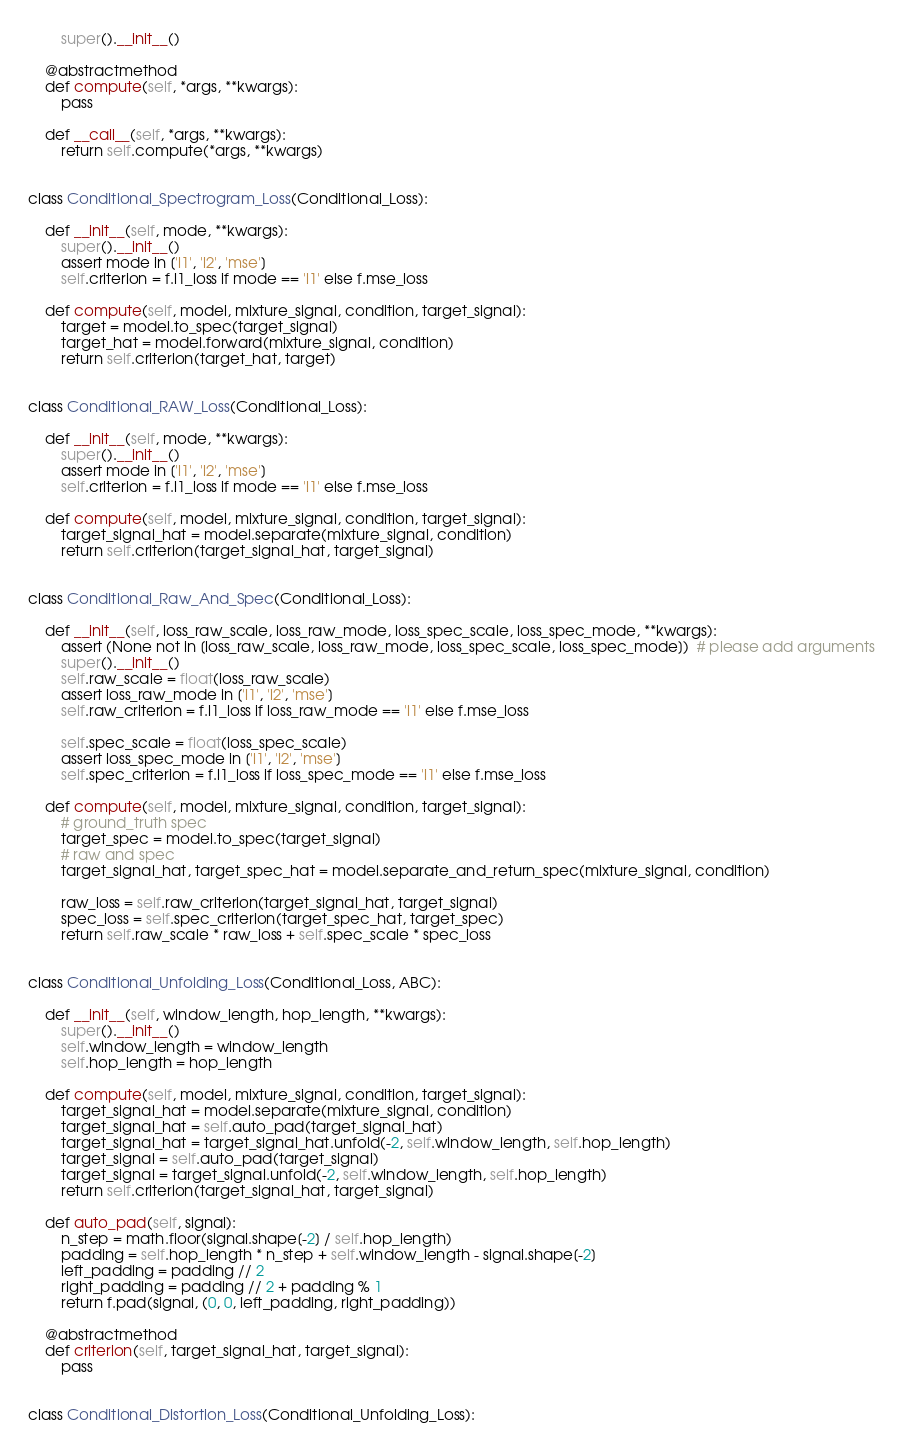Convert code to text. <code><loc_0><loc_0><loc_500><loc_500><_Python_>        super().__init__()

    @abstractmethod
    def compute(self, *args, **kwargs):
        pass

    def __call__(self, *args, **kwargs):
        return self.compute(*args, **kwargs)


class Conditional_Spectrogram_Loss(Conditional_Loss):

    def __init__(self, mode, **kwargs):
        super().__init__()
        assert mode in ['l1', 'l2', 'mse']
        self.criterion = f.l1_loss if mode == 'l1' else f.mse_loss

    def compute(self, model, mixture_signal, condition, target_signal):
        target = model.to_spec(target_signal)
        target_hat = model.forward(mixture_signal, condition)
        return self.criterion(target_hat, target)


class Conditional_RAW_Loss(Conditional_Loss):

    def __init__(self, mode, **kwargs):
        super().__init__()
        assert mode in ['l1', 'l2', 'mse']
        self.criterion = f.l1_loss if mode == 'l1' else f.mse_loss

    def compute(self, model, mixture_signal, condition, target_signal):
        target_signal_hat = model.separate(mixture_signal, condition)
        return self.criterion(target_signal_hat, target_signal)


class Conditional_Raw_And_Spec(Conditional_Loss):

    def __init__(self, loss_raw_scale, loss_raw_mode, loss_spec_scale, loss_spec_mode, **kwargs):
        assert (None not in [loss_raw_scale, loss_raw_mode, loss_spec_scale, loss_spec_mode])  # please add arguments
        super().__init__()
        self.raw_scale = float(loss_raw_scale)
        assert loss_raw_mode in ['l1', 'l2', 'mse']
        self.raw_criterion = f.l1_loss if loss_raw_mode == 'l1' else f.mse_loss

        self.spec_scale = float(loss_spec_scale)
        assert loss_spec_mode in ['l1', 'l2', 'mse']
        self.spec_criterion = f.l1_loss if loss_spec_mode == 'l1' else f.mse_loss

    def compute(self, model, mixture_signal, condition, target_signal):
        # ground_truth spec
        target_spec = model.to_spec(target_signal)
        # raw and spec
        target_signal_hat, target_spec_hat = model.separate_and_return_spec(mixture_signal, condition)

        raw_loss = self.raw_criterion(target_signal_hat, target_signal)
        spec_loss = self.spec_criterion(target_spec_hat, target_spec)
        return self.raw_scale * raw_loss + self.spec_scale * spec_loss


class Conditional_Unfolding_Loss(Conditional_Loss, ABC):

    def __init__(self, window_length, hop_length, **kwargs):
        super().__init__()
        self.window_length = window_length
        self.hop_length = hop_length

    def compute(self, model, mixture_signal, condition, target_signal):
        target_signal_hat = model.separate(mixture_signal, condition)
        target_signal_hat = self.auto_pad(target_signal_hat)
        target_signal_hat = target_signal_hat.unfold(-2, self.window_length, self.hop_length)
        target_signal = self.auto_pad(target_signal)
        target_signal = target_signal.unfold(-2, self.window_length, self.hop_length)
        return self.criterion(target_signal_hat, target_signal)

    def auto_pad(self, signal):
        n_step = math.floor(signal.shape[-2] / self.hop_length)
        padding = self.hop_length * n_step + self.window_length - signal.shape[-2]
        left_padding = padding // 2
        right_padding = padding // 2 + padding % 1
        return f.pad(signal, (0, 0, left_padding, right_padding))

    @abstractmethod
    def criterion(self, target_signal_hat, target_signal):
        pass


class Conditional_Distortion_Loss(Conditional_Unfolding_Loss):
</code> 